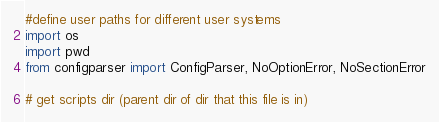Convert code to text. <code><loc_0><loc_0><loc_500><loc_500><_Python_>#define user paths for different user systems
import os
import pwd
from configparser import ConfigParser, NoOptionError, NoSectionError

# get scripts dir (parent dir of dir that this file is in)</code> 